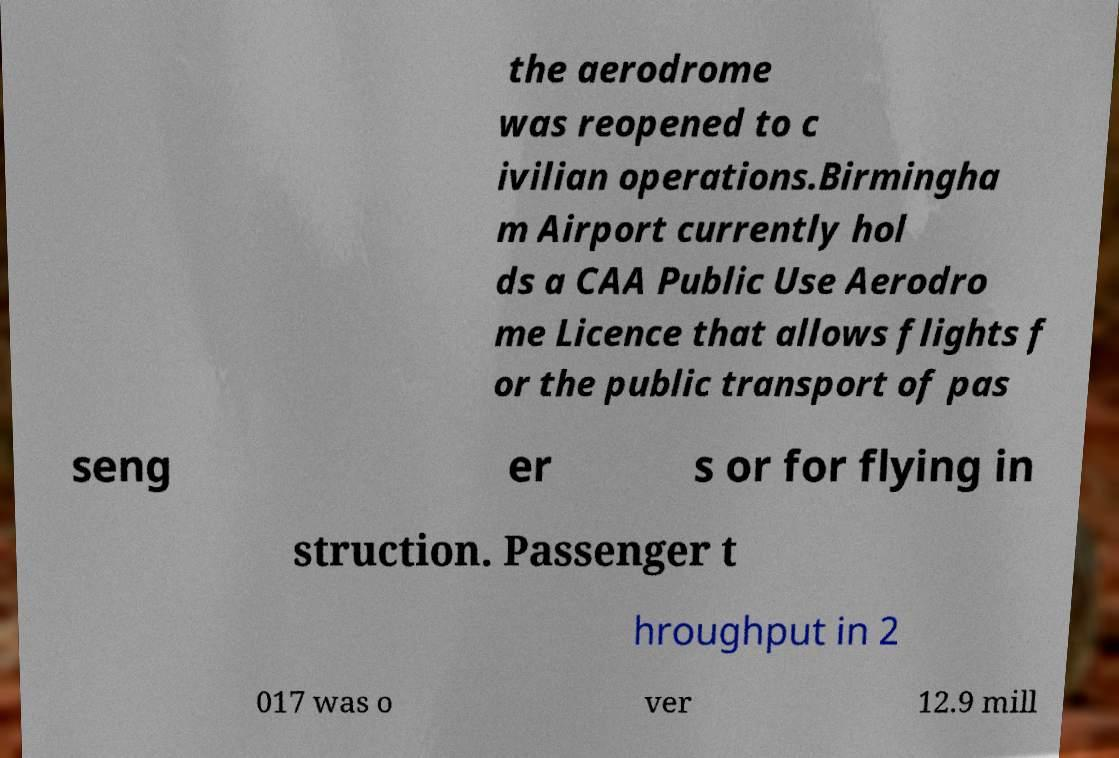Could you extract and type out the text from this image? the aerodrome was reopened to c ivilian operations.Birmingha m Airport currently hol ds a CAA Public Use Aerodro me Licence that allows flights f or the public transport of pas seng er s or for flying in struction. Passenger t hroughput in 2 017 was o ver 12.9 mill 